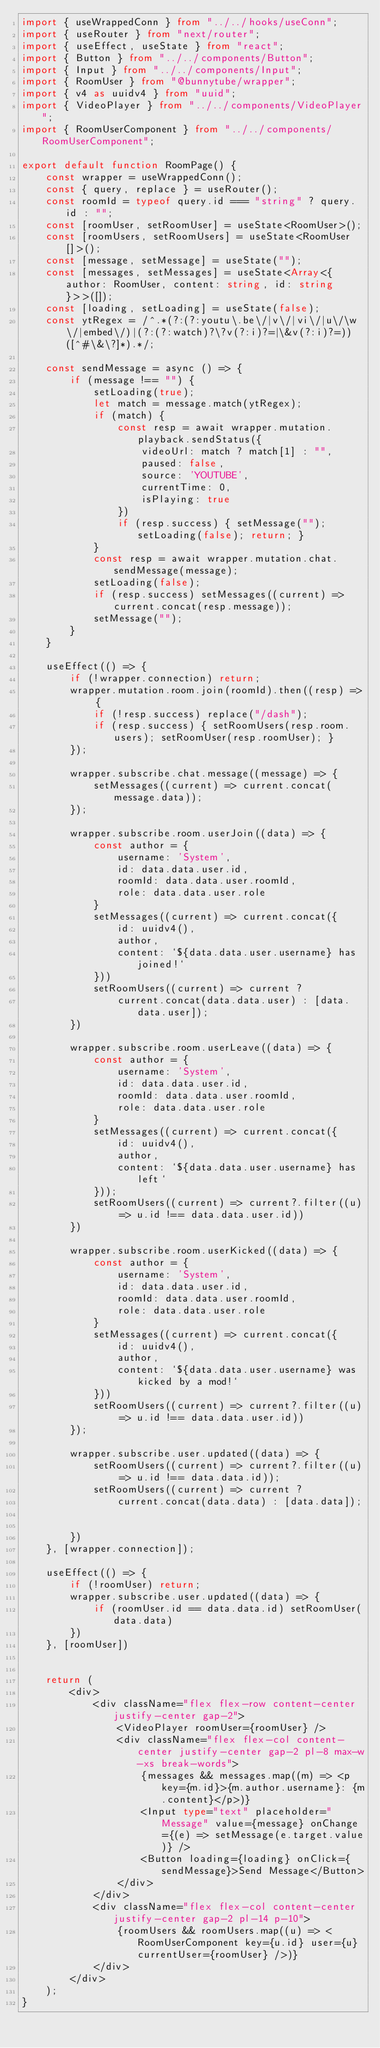Convert code to text. <code><loc_0><loc_0><loc_500><loc_500><_TypeScript_>import { useWrappedConn } from "../../hooks/useConn";
import { useRouter } from "next/router";
import { useEffect, useState } from "react";
import { Button } from "../../components/Button";
import { Input } from "../../components/Input";
import { RoomUser } from "@bunnytube/wrapper";
import { v4 as uuidv4 } from "uuid";
import { VideoPlayer } from "../../components/VideoPlayer";
import { RoomUserComponent } from "../../components/RoomUserComponent";

export default function RoomPage() {
    const wrapper = useWrappedConn();
    const { query, replace } = useRouter();
    const roomId = typeof query.id === "string" ? query.id : "";
    const [roomUser, setRoomUser] = useState<RoomUser>();
    const [roomUsers, setRoomUsers] = useState<RoomUser[]>();
    const [message, setMessage] = useState("");
    const [messages, setMessages] = useState<Array<{ author: RoomUser, content: string, id: string }>>([]);
    const [loading, setLoading] = useState(false);
    const ytRegex = /^.*(?:(?:youtu\.be\/|v\/|vi\/|u\/\w\/|embed\/)|(?:(?:watch)?\?v(?:i)?=|\&v(?:i)?=))([^#\&\?]*).*/;

    const sendMessage = async () => {
        if (message !== "") {
            setLoading(true);
            let match = message.match(ytRegex);
            if (match) {
                const resp = await wrapper.mutation.playback.sendStatus({
                    videoUrl: match ? match[1] : "",
                    paused: false,
                    source: 'YOUTUBE',
                    currentTime: 0,
                    isPlaying: true
                })
                if (resp.success) { setMessage(""); setLoading(false); return; }
            }
            const resp = await wrapper.mutation.chat.sendMessage(message);
            setLoading(false);
            if (resp.success) setMessages((current) => current.concat(resp.message));
            setMessage("");
        }
    }

    useEffect(() => {
        if (!wrapper.connection) return;
        wrapper.mutation.room.join(roomId).then((resp) => {
            if (!resp.success) replace("/dash");
            if (resp.success) { setRoomUsers(resp.room.users); setRoomUser(resp.roomUser); }
        });

        wrapper.subscribe.chat.message((message) => {
            setMessages((current) => current.concat(message.data));
        });

        wrapper.subscribe.room.userJoin((data) => {
            const author = {
                username: 'System',
                id: data.data.user.id,
                roomId: data.data.user.roomId,
                role: data.data.user.role
            }
            setMessages((current) => current.concat({
                id: uuidv4(),
                author,
                content: `${data.data.user.username} has joined!`
            }))
            setRoomUsers((current) => current ?
                current.concat(data.data.user) : [data.data.user]);
        })

        wrapper.subscribe.room.userLeave((data) => {
            const author = {
                username: 'System',
                id: data.data.user.id,
                roomId: data.data.user.roomId,
                role: data.data.user.role
            }
            setMessages((current) => current.concat({
                id: uuidv4(),
                author,
                content: `${data.data.user.username} has left`
            }));
            setRoomUsers((current) => current?.filter((u) => u.id !== data.data.user.id))
        })

        wrapper.subscribe.room.userKicked((data) => {
            const author = {
                username: 'System',
                id: data.data.user.id,
                roomId: data.data.user.roomId,
                role: data.data.user.role
            }
            setMessages((current) => current.concat({
                id: uuidv4(),
                author,
                content: `${data.data.user.username} was kicked by a mod!`
            }))
            setRoomUsers((current) => current?.filter((u) => u.id !== data.data.user.id))
        });

        wrapper.subscribe.user.updated((data) => {
            setRoomUsers((current) => current?.filter((u) => u.id !== data.data.id));
            setRoomUsers((current) => current ?
                current.concat(data.data) : [data.data]);


        })
    }, [wrapper.connection]);

    useEffect(() => {
        if (!roomUser) return;
        wrapper.subscribe.user.updated((data) => {
            if (roomUser.id == data.data.id) setRoomUser(data.data)
        })
    }, [roomUser])


    return (
        <div>
            <div className="flex flex-row content-center justify-center gap-2">
                <VideoPlayer roomUser={roomUser} />
                <div className="flex flex-col content-center justify-center gap-2 pl-8 max-w-xs break-words">
                    {messages && messages.map((m) => <p key={m.id}>{m.author.username}: {m.content}</p>)}
                    <Input type="text" placeholder="Message" value={message} onChange={(e) => setMessage(e.target.value)} />
                    <Button loading={loading} onClick={sendMessage}>Send Message</Button>
                </div>
            </div>
            <div className="flex flex-col content-center justify-center gap-2 pl-14 p-10">
                {roomUsers && roomUsers.map((u) => <RoomUserComponent key={u.id} user={u} currentUser={roomUser} />)}
            </div>
        </div>
    );
}
</code> 